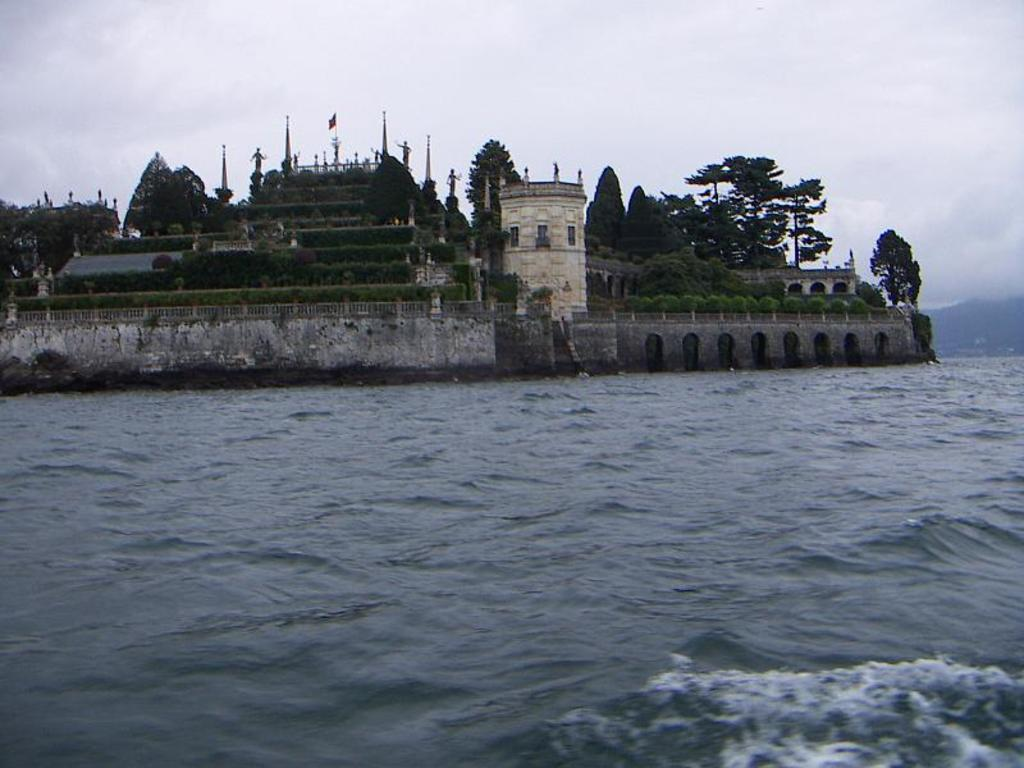What is the main feature in the front of the image? There is a water lake in the front of the image. What can be seen in the background of the image? There are monuments and trees in the background of the image. How would you describe the sky in the image? The sky is cloudy in the image. What type of toothpaste is being used to clean the room in the image? There is no room or toothpaste present in the image; it features a water lake, monuments, trees, and a cloudy sky. 